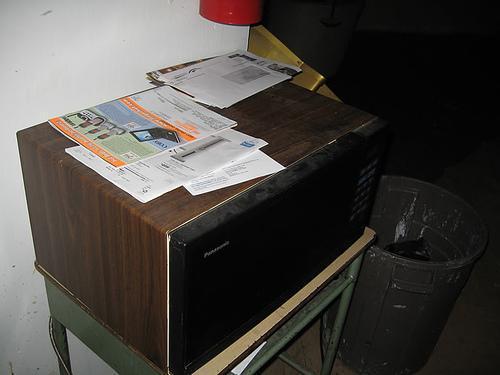How many people do you see in this boat?
Give a very brief answer. 0. 